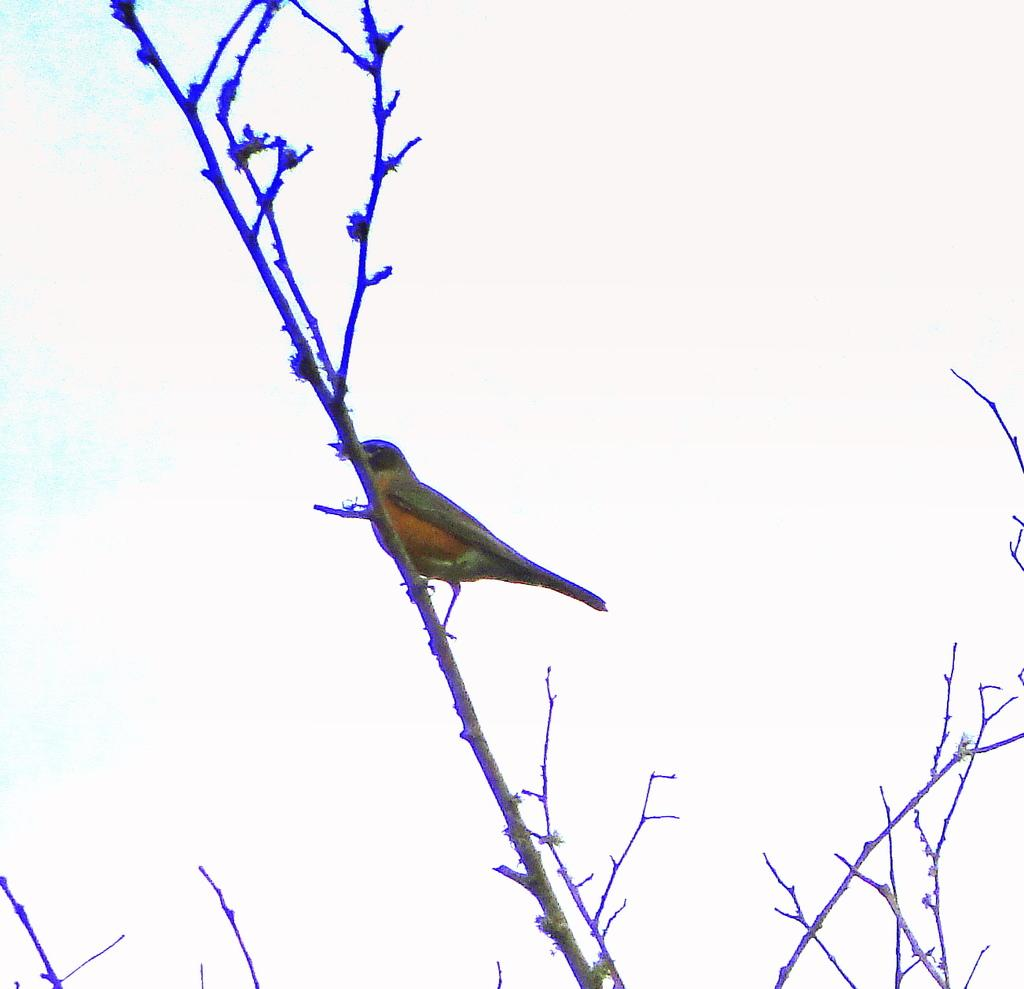What type of animal can be seen in the image? There is a bird in the image. Where is the bird located in the image? The bird is sitting on a branch. What is the branch a part of? The branch is part of a tree. What type of protest is happening in the image? There is no protest present in the image; it features a bird sitting on a branch. What type of bushes can be seen in the image? There are no bushes visible in the image; it only shows a bird sitting on a branch of a tree. 